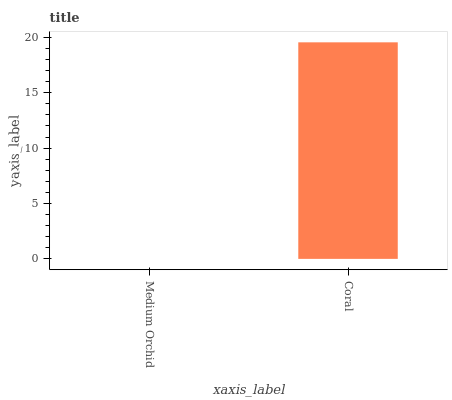Is Medium Orchid the minimum?
Answer yes or no. Yes. Is Coral the maximum?
Answer yes or no. Yes. Is Coral the minimum?
Answer yes or no. No. Is Coral greater than Medium Orchid?
Answer yes or no. Yes. Is Medium Orchid less than Coral?
Answer yes or no. Yes. Is Medium Orchid greater than Coral?
Answer yes or no. No. Is Coral less than Medium Orchid?
Answer yes or no. No. Is Coral the high median?
Answer yes or no. Yes. Is Medium Orchid the low median?
Answer yes or no. Yes. Is Medium Orchid the high median?
Answer yes or no. No. Is Coral the low median?
Answer yes or no. No. 